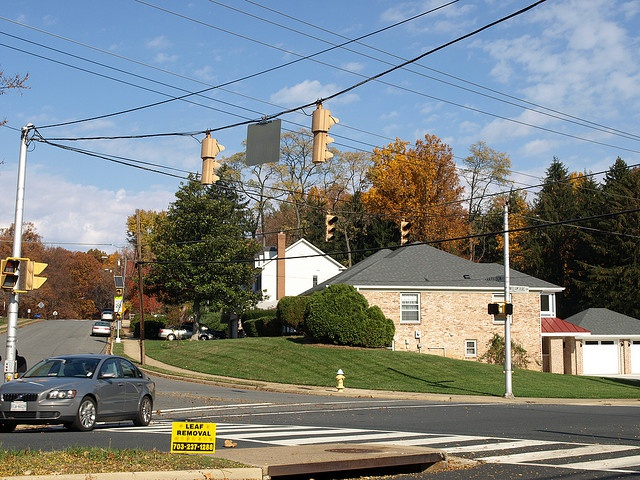Describe the objects in this image and their specific colors. I can see car in gray, black, and darkgray tones, traffic light in gray, black, khaki, and maroon tones, traffic light in gray and tan tones, traffic light in gray and tan tones, and car in gray, black, white, and darkgray tones in this image. 